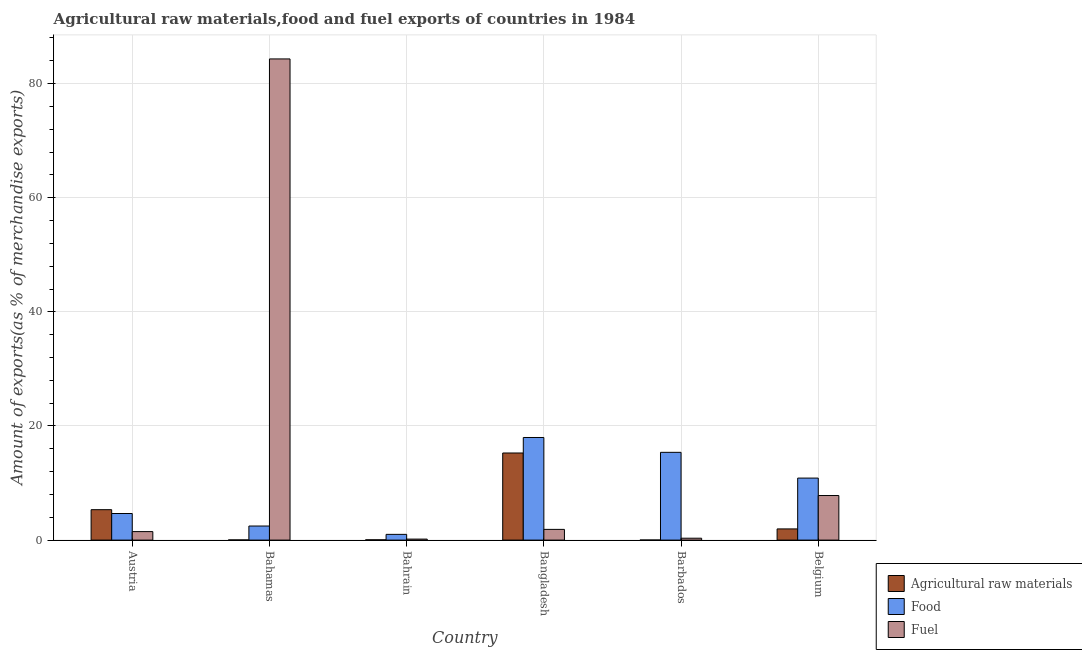Are the number of bars per tick equal to the number of legend labels?
Give a very brief answer. Yes. What is the label of the 5th group of bars from the left?
Give a very brief answer. Barbados. In how many cases, is the number of bars for a given country not equal to the number of legend labels?
Offer a very short reply. 0. What is the percentage of fuel exports in Bangladesh?
Keep it short and to the point. 1.88. Across all countries, what is the maximum percentage of food exports?
Ensure brevity in your answer.  17.98. Across all countries, what is the minimum percentage of raw materials exports?
Your response must be concise. 0.01. In which country was the percentage of food exports minimum?
Ensure brevity in your answer.  Bahrain. What is the total percentage of food exports in the graph?
Your response must be concise. 52.37. What is the difference between the percentage of fuel exports in Austria and that in Bangladesh?
Offer a very short reply. -0.39. What is the difference between the percentage of raw materials exports in Bangladesh and the percentage of food exports in Belgium?
Offer a terse response. 4.4. What is the average percentage of raw materials exports per country?
Give a very brief answer. 3.77. What is the difference between the percentage of fuel exports and percentage of raw materials exports in Bahrain?
Make the answer very short. 0.13. What is the ratio of the percentage of fuel exports in Bangladesh to that in Belgium?
Offer a terse response. 0.24. Is the difference between the percentage of food exports in Bahamas and Bangladesh greater than the difference between the percentage of raw materials exports in Bahamas and Bangladesh?
Your response must be concise. No. What is the difference between the highest and the second highest percentage of fuel exports?
Give a very brief answer. 76.52. What is the difference between the highest and the lowest percentage of fuel exports?
Offer a very short reply. 84.15. In how many countries, is the percentage of food exports greater than the average percentage of food exports taken over all countries?
Keep it short and to the point. 3. What does the 3rd bar from the left in Barbados represents?
Your response must be concise. Fuel. What does the 2nd bar from the right in Bahamas represents?
Keep it short and to the point. Food. Is it the case that in every country, the sum of the percentage of raw materials exports and percentage of food exports is greater than the percentage of fuel exports?
Offer a terse response. No. Are all the bars in the graph horizontal?
Your answer should be compact. No. Are the values on the major ticks of Y-axis written in scientific E-notation?
Give a very brief answer. No. Where does the legend appear in the graph?
Offer a terse response. Bottom right. How are the legend labels stacked?
Give a very brief answer. Vertical. What is the title of the graph?
Ensure brevity in your answer.  Agricultural raw materials,food and fuel exports of countries in 1984. Does "Textiles and clothing" appear as one of the legend labels in the graph?
Your answer should be very brief. No. What is the label or title of the Y-axis?
Ensure brevity in your answer.  Amount of exports(as % of merchandise exports). What is the Amount of exports(as % of merchandise exports) in Agricultural raw materials in Austria?
Offer a very short reply. 5.33. What is the Amount of exports(as % of merchandise exports) in Food in Austria?
Your response must be concise. 4.66. What is the Amount of exports(as % of merchandise exports) of Fuel in Austria?
Keep it short and to the point. 1.49. What is the Amount of exports(as % of merchandise exports) in Agricultural raw materials in Bahamas?
Provide a succinct answer. 0.03. What is the Amount of exports(as % of merchandise exports) in Food in Bahamas?
Make the answer very short. 2.47. What is the Amount of exports(as % of merchandise exports) of Fuel in Bahamas?
Give a very brief answer. 84.33. What is the Amount of exports(as % of merchandise exports) in Agricultural raw materials in Bahrain?
Provide a succinct answer. 0.05. What is the Amount of exports(as % of merchandise exports) in Food in Bahrain?
Your answer should be compact. 1. What is the Amount of exports(as % of merchandise exports) of Fuel in Bahrain?
Make the answer very short. 0.18. What is the Amount of exports(as % of merchandise exports) in Agricultural raw materials in Bangladesh?
Ensure brevity in your answer.  15.27. What is the Amount of exports(as % of merchandise exports) in Food in Bangladesh?
Keep it short and to the point. 17.98. What is the Amount of exports(as % of merchandise exports) in Fuel in Bangladesh?
Your answer should be very brief. 1.88. What is the Amount of exports(as % of merchandise exports) in Agricultural raw materials in Barbados?
Your answer should be very brief. 0.01. What is the Amount of exports(as % of merchandise exports) of Food in Barbados?
Offer a very short reply. 15.38. What is the Amount of exports(as % of merchandise exports) in Fuel in Barbados?
Provide a short and direct response. 0.33. What is the Amount of exports(as % of merchandise exports) of Agricultural raw materials in Belgium?
Ensure brevity in your answer.  1.96. What is the Amount of exports(as % of merchandise exports) of Food in Belgium?
Make the answer very short. 10.87. What is the Amount of exports(as % of merchandise exports) in Fuel in Belgium?
Provide a short and direct response. 7.81. Across all countries, what is the maximum Amount of exports(as % of merchandise exports) in Agricultural raw materials?
Offer a terse response. 15.27. Across all countries, what is the maximum Amount of exports(as % of merchandise exports) in Food?
Keep it short and to the point. 17.98. Across all countries, what is the maximum Amount of exports(as % of merchandise exports) of Fuel?
Ensure brevity in your answer.  84.33. Across all countries, what is the minimum Amount of exports(as % of merchandise exports) of Agricultural raw materials?
Your answer should be compact. 0.01. Across all countries, what is the minimum Amount of exports(as % of merchandise exports) of Food?
Ensure brevity in your answer.  1. Across all countries, what is the minimum Amount of exports(as % of merchandise exports) of Fuel?
Offer a terse response. 0.18. What is the total Amount of exports(as % of merchandise exports) of Agricultural raw materials in the graph?
Offer a very short reply. 22.65. What is the total Amount of exports(as % of merchandise exports) of Food in the graph?
Your answer should be very brief. 52.37. What is the total Amount of exports(as % of merchandise exports) in Fuel in the graph?
Make the answer very short. 96.01. What is the difference between the Amount of exports(as % of merchandise exports) of Agricultural raw materials in Austria and that in Bahamas?
Provide a short and direct response. 5.3. What is the difference between the Amount of exports(as % of merchandise exports) in Food in Austria and that in Bahamas?
Keep it short and to the point. 2.19. What is the difference between the Amount of exports(as % of merchandise exports) in Fuel in Austria and that in Bahamas?
Give a very brief answer. -82.84. What is the difference between the Amount of exports(as % of merchandise exports) of Agricultural raw materials in Austria and that in Bahrain?
Offer a very short reply. 5.28. What is the difference between the Amount of exports(as % of merchandise exports) in Food in Austria and that in Bahrain?
Make the answer very short. 3.66. What is the difference between the Amount of exports(as % of merchandise exports) in Fuel in Austria and that in Bahrain?
Offer a very short reply. 1.31. What is the difference between the Amount of exports(as % of merchandise exports) of Agricultural raw materials in Austria and that in Bangladesh?
Provide a short and direct response. -9.94. What is the difference between the Amount of exports(as % of merchandise exports) of Food in Austria and that in Bangladesh?
Offer a very short reply. -13.32. What is the difference between the Amount of exports(as % of merchandise exports) of Fuel in Austria and that in Bangladesh?
Offer a very short reply. -0.39. What is the difference between the Amount of exports(as % of merchandise exports) of Agricultural raw materials in Austria and that in Barbados?
Offer a very short reply. 5.32. What is the difference between the Amount of exports(as % of merchandise exports) in Food in Austria and that in Barbados?
Offer a very short reply. -10.72. What is the difference between the Amount of exports(as % of merchandise exports) in Fuel in Austria and that in Barbados?
Ensure brevity in your answer.  1.16. What is the difference between the Amount of exports(as % of merchandise exports) in Agricultural raw materials in Austria and that in Belgium?
Provide a short and direct response. 3.37. What is the difference between the Amount of exports(as % of merchandise exports) in Food in Austria and that in Belgium?
Your answer should be very brief. -6.21. What is the difference between the Amount of exports(as % of merchandise exports) of Fuel in Austria and that in Belgium?
Your answer should be very brief. -6.32. What is the difference between the Amount of exports(as % of merchandise exports) of Agricultural raw materials in Bahamas and that in Bahrain?
Provide a succinct answer. -0.02. What is the difference between the Amount of exports(as % of merchandise exports) in Food in Bahamas and that in Bahrain?
Your response must be concise. 1.46. What is the difference between the Amount of exports(as % of merchandise exports) in Fuel in Bahamas and that in Bahrain?
Provide a short and direct response. 84.15. What is the difference between the Amount of exports(as % of merchandise exports) in Agricultural raw materials in Bahamas and that in Bangladesh?
Ensure brevity in your answer.  -15.24. What is the difference between the Amount of exports(as % of merchandise exports) in Food in Bahamas and that in Bangladesh?
Your answer should be compact. -15.51. What is the difference between the Amount of exports(as % of merchandise exports) of Fuel in Bahamas and that in Bangladesh?
Your response must be concise. 82.45. What is the difference between the Amount of exports(as % of merchandise exports) in Agricultural raw materials in Bahamas and that in Barbados?
Offer a very short reply. 0.02. What is the difference between the Amount of exports(as % of merchandise exports) in Food in Bahamas and that in Barbados?
Provide a short and direct response. -12.91. What is the difference between the Amount of exports(as % of merchandise exports) in Fuel in Bahamas and that in Barbados?
Provide a short and direct response. 84. What is the difference between the Amount of exports(as % of merchandise exports) in Agricultural raw materials in Bahamas and that in Belgium?
Keep it short and to the point. -1.93. What is the difference between the Amount of exports(as % of merchandise exports) in Food in Bahamas and that in Belgium?
Your response must be concise. -8.4. What is the difference between the Amount of exports(as % of merchandise exports) in Fuel in Bahamas and that in Belgium?
Your answer should be compact. 76.52. What is the difference between the Amount of exports(as % of merchandise exports) of Agricultural raw materials in Bahrain and that in Bangladesh?
Your answer should be very brief. -15.22. What is the difference between the Amount of exports(as % of merchandise exports) of Food in Bahrain and that in Bangladesh?
Your answer should be very brief. -16.98. What is the difference between the Amount of exports(as % of merchandise exports) in Fuel in Bahrain and that in Bangladesh?
Provide a succinct answer. -1.7. What is the difference between the Amount of exports(as % of merchandise exports) of Agricultural raw materials in Bahrain and that in Barbados?
Make the answer very short. 0.04. What is the difference between the Amount of exports(as % of merchandise exports) in Food in Bahrain and that in Barbados?
Provide a succinct answer. -14.38. What is the difference between the Amount of exports(as % of merchandise exports) in Fuel in Bahrain and that in Barbados?
Provide a succinct answer. -0.15. What is the difference between the Amount of exports(as % of merchandise exports) in Agricultural raw materials in Bahrain and that in Belgium?
Provide a short and direct response. -1.91. What is the difference between the Amount of exports(as % of merchandise exports) of Food in Bahrain and that in Belgium?
Offer a terse response. -9.87. What is the difference between the Amount of exports(as % of merchandise exports) in Fuel in Bahrain and that in Belgium?
Give a very brief answer. -7.64. What is the difference between the Amount of exports(as % of merchandise exports) of Agricultural raw materials in Bangladesh and that in Barbados?
Your answer should be very brief. 15.26. What is the difference between the Amount of exports(as % of merchandise exports) in Food in Bangladesh and that in Barbados?
Your answer should be compact. 2.6. What is the difference between the Amount of exports(as % of merchandise exports) in Fuel in Bangladesh and that in Barbados?
Make the answer very short. 1.55. What is the difference between the Amount of exports(as % of merchandise exports) of Agricultural raw materials in Bangladesh and that in Belgium?
Provide a short and direct response. 13.31. What is the difference between the Amount of exports(as % of merchandise exports) of Food in Bangladesh and that in Belgium?
Give a very brief answer. 7.11. What is the difference between the Amount of exports(as % of merchandise exports) of Fuel in Bangladesh and that in Belgium?
Your answer should be very brief. -5.93. What is the difference between the Amount of exports(as % of merchandise exports) in Agricultural raw materials in Barbados and that in Belgium?
Keep it short and to the point. -1.95. What is the difference between the Amount of exports(as % of merchandise exports) in Food in Barbados and that in Belgium?
Your response must be concise. 4.51. What is the difference between the Amount of exports(as % of merchandise exports) of Fuel in Barbados and that in Belgium?
Your answer should be compact. -7.48. What is the difference between the Amount of exports(as % of merchandise exports) of Agricultural raw materials in Austria and the Amount of exports(as % of merchandise exports) of Food in Bahamas?
Keep it short and to the point. 2.86. What is the difference between the Amount of exports(as % of merchandise exports) of Agricultural raw materials in Austria and the Amount of exports(as % of merchandise exports) of Fuel in Bahamas?
Offer a very short reply. -79. What is the difference between the Amount of exports(as % of merchandise exports) in Food in Austria and the Amount of exports(as % of merchandise exports) in Fuel in Bahamas?
Provide a short and direct response. -79.67. What is the difference between the Amount of exports(as % of merchandise exports) in Agricultural raw materials in Austria and the Amount of exports(as % of merchandise exports) in Food in Bahrain?
Provide a succinct answer. 4.33. What is the difference between the Amount of exports(as % of merchandise exports) in Agricultural raw materials in Austria and the Amount of exports(as % of merchandise exports) in Fuel in Bahrain?
Your response must be concise. 5.16. What is the difference between the Amount of exports(as % of merchandise exports) of Food in Austria and the Amount of exports(as % of merchandise exports) of Fuel in Bahrain?
Offer a very short reply. 4.48. What is the difference between the Amount of exports(as % of merchandise exports) of Agricultural raw materials in Austria and the Amount of exports(as % of merchandise exports) of Food in Bangladesh?
Provide a succinct answer. -12.65. What is the difference between the Amount of exports(as % of merchandise exports) of Agricultural raw materials in Austria and the Amount of exports(as % of merchandise exports) of Fuel in Bangladesh?
Your answer should be compact. 3.45. What is the difference between the Amount of exports(as % of merchandise exports) of Food in Austria and the Amount of exports(as % of merchandise exports) of Fuel in Bangladesh?
Give a very brief answer. 2.78. What is the difference between the Amount of exports(as % of merchandise exports) of Agricultural raw materials in Austria and the Amount of exports(as % of merchandise exports) of Food in Barbados?
Offer a terse response. -10.05. What is the difference between the Amount of exports(as % of merchandise exports) in Agricultural raw materials in Austria and the Amount of exports(as % of merchandise exports) in Fuel in Barbados?
Your answer should be compact. 5. What is the difference between the Amount of exports(as % of merchandise exports) of Food in Austria and the Amount of exports(as % of merchandise exports) of Fuel in Barbados?
Keep it short and to the point. 4.33. What is the difference between the Amount of exports(as % of merchandise exports) of Agricultural raw materials in Austria and the Amount of exports(as % of merchandise exports) of Food in Belgium?
Ensure brevity in your answer.  -5.54. What is the difference between the Amount of exports(as % of merchandise exports) of Agricultural raw materials in Austria and the Amount of exports(as % of merchandise exports) of Fuel in Belgium?
Keep it short and to the point. -2.48. What is the difference between the Amount of exports(as % of merchandise exports) of Food in Austria and the Amount of exports(as % of merchandise exports) of Fuel in Belgium?
Provide a short and direct response. -3.15. What is the difference between the Amount of exports(as % of merchandise exports) in Agricultural raw materials in Bahamas and the Amount of exports(as % of merchandise exports) in Food in Bahrain?
Offer a terse response. -0.97. What is the difference between the Amount of exports(as % of merchandise exports) of Agricultural raw materials in Bahamas and the Amount of exports(as % of merchandise exports) of Fuel in Bahrain?
Offer a terse response. -0.14. What is the difference between the Amount of exports(as % of merchandise exports) of Food in Bahamas and the Amount of exports(as % of merchandise exports) of Fuel in Bahrain?
Give a very brief answer. 2.29. What is the difference between the Amount of exports(as % of merchandise exports) in Agricultural raw materials in Bahamas and the Amount of exports(as % of merchandise exports) in Food in Bangladesh?
Your response must be concise. -17.95. What is the difference between the Amount of exports(as % of merchandise exports) in Agricultural raw materials in Bahamas and the Amount of exports(as % of merchandise exports) in Fuel in Bangladesh?
Your response must be concise. -1.85. What is the difference between the Amount of exports(as % of merchandise exports) of Food in Bahamas and the Amount of exports(as % of merchandise exports) of Fuel in Bangladesh?
Your response must be concise. 0.59. What is the difference between the Amount of exports(as % of merchandise exports) of Agricultural raw materials in Bahamas and the Amount of exports(as % of merchandise exports) of Food in Barbados?
Your answer should be very brief. -15.35. What is the difference between the Amount of exports(as % of merchandise exports) of Agricultural raw materials in Bahamas and the Amount of exports(as % of merchandise exports) of Fuel in Barbados?
Offer a terse response. -0.3. What is the difference between the Amount of exports(as % of merchandise exports) in Food in Bahamas and the Amount of exports(as % of merchandise exports) in Fuel in Barbados?
Offer a very short reply. 2.14. What is the difference between the Amount of exports(as % of merchandise exports) in Agricultural raw materials in Bahamas and the Amount of exports(as % of merchandise exports) in Food in Belgium?
Provide a short and direct response. -10.84. What is the difference between the Amount of exports(as % of merchandise exports) of Agricultural raw materials in Bahamas and the Amount of exports(as % of merchandise exports) of Fuel in Belgium?
Make the answer very short. -7.78. What is the difference between the Amount of exports(as % of merchandise exports) in Food in Bahamas and the Amount of exports(as % of merchandise exports) in Fuel in Belgium?
Your answer should be compact. -5.34. What is the difference between the Amount of exports(as % of merchandise exports) of Agricultural raw materials in Bahrain and the Amount of exports(as % of merchandise exports) of Food in Bangladesh?
Your answer should be very brief. -17.93. What is the difference between the Amount of exports(as % of merchandise exports) of Agricultural raw materials in Bahrain and the Amount of exports(as % of merchandise exports) of Fuel in Bangladesh?
Your response must be concise. -1.83. What is the difference between the Amount of exports(as % of merchandise exports) of Food in Bahrain and the Amount of exports(as % of merchandise exports) of Fuel in Bangladesh?
Provide a short and direct response. -0.87. What is the difference between the Amount of exports(as % of merchandise exports) of Agricultural raw materials in Bahrain and the Amount of exports(as % of merchandise exports) of Food in Barbados?
Ensure brevity in your answer.  -15.33. What is the difference between the Amount of exports(as % of merchandise exports) of Agricultural raw materials in Bahrain and the Amount of exports(as % of merchandise exports) of Fuel in Barbados?
Offer a very short reply. -0.28. What is the difference between the Amount of exports(as % of merchandise exports) of Food in Bahrain and the Amount of exports(as % of merchandise exports) of Fuel in Barbados?
Offer a very short reply. 0.67. What is the difference between the Amount of exports(as % of merchandise exports) of Agricultural raw materials in Bahrain and the Amount of exports(as % of merchandise exports) of Food in Belgium?
Make the answer very short. -10.82. What is the difference between the Amount of exports(as % of merchandise exports) of Agricultural raw materials in Bahrain and the Amount of exports(as % of merchandise exports) of Fuel in Belgium?
Keep it short and to the point. -7.76. What is the difference between the Amount of exports(as % of merchandise exports) of Food in Bahrain and the Amount of exports(as % of merchandise exports) of Fuel in Belgium?
Offer a terse response. -6.81. What is the difference between the Amount of exports(as % of merchandise exports) of Agricultural raw materials in Bangladesh and the Amount of exports(as % of merchandise exports) of Food in Barbados?
Keep it short and to the point. -0.11. What is the difference between the Amount of exports(as % of merchandise exports) of Agricultural raw materials in Bangladesh and the Amount of exports(as % of merchandise exports) of Fuel in Barbados?
Your response must be concise. 14.94. What is the difference between the Amount of exports(as % of merchandise exports) of Food in Bangladesh and the Amount of exports(as % of merchandise exports) of Fuel in Barbados?
Your answer should be compact. 17.65. What is the difference between the Amount of exports(as % of merchandise exports) of Agricultural raw materials in Bangladesh and the Amount of exports(as % of merchandise exports) of Food in Belgium?
Ensure brevity in your answer.  4.4. What is the difference between the Amount of exports(as % of merchandise exports) of Agricultural raw materials in Bangladesh and the Amount of exports(as % of merchandise exports) of Fuel in Belgium?
Your response must be concise. 7.45. What is the difference between the Amount of exports(as % of merchandise exports) of Food in Bangladesh and the Amount of exports(as % of merchandise exports) of Fuel in Belgium?
Your answer should be very brief. 10.17. What is the difference between the Amount of exports(as % of merchandise exports) in Agricultural raw materials in Barbados and the Amount of exports(as % of merchandise exports) in Food in Belgium?
Give a very brief answer. -10.86. What is the difference between the Amount of exports(as % of merchandise exports) in Agricultural raw materials in Barbados and the Amount of exports(as % of merchandise exports) in Fuel in Belgium?
Give a very brief answer. -7.8. What is the difference between the Amount of exports(as % of merchandise exports) of Food in Barbados and the Amount of exports(as % of merchandise exports) of Fuel in Belgium?
Make the answer very short. 7.57. What is the average Amount of exports(as % of merchandise exports) of Agricultural raw materials per country?
Provide a short and direct response. 3.77. What is the average Amount of exports(as % of merchandise exports) of Food per country?
Offer a terse response. 8.73. What is the average Amount of exports(as % of merchandise exports) of Fuel per country?
Give a very brief answer. 16. What is the difference between the Amount of exports(as % of merchandise exports) in Agricultural raw materials and Amount of exports(as % of merchandise exports) in Food in Austria?
Make the answer very short. 0.67. What is the difference between the Amount of exports(as % of merchandise exports) in Agricultural raw materials and Amount of exports(as % of merchandise exports) in Fuel in Austria?
Your response must be concise. 3.84. What is the difference between the Amount of exports(as % of merchandise exports) of Food and Amount of exports(as % of merchandise exports) of Fuel in Austria?
Your response must be concise. 3.17. What is the difference between the Amount of exports(as % of merchandise exports) of Agricultural raw materials and Amount of exports(as % of merchandise exports) of Food in Bahamas?
Your answer should be very brief. -2.44. What is the difference between the Amount of exports(as % of merchandise exports) of Agricultural raw materials and Amount of exports(as % of merchandise exports) of Fuel in Bahamas?
Ensure brevity in your answer.  -84.3. What is the difference between the Amount of exports(as % of merchandise exports) of Food and Amount of exports(as % of merchandise exports) of Fuel in Bahamas?
Make the answer very short. -81.86. What is the difference between the Amount of exports(as % of merchandise exports) in Agricultural raw materials and Amount of exports(as % of merchandise exports) in Food in Bahrain?
Your answer should be very brief. -0.95. What is the difference between the Amount of exports(as % of merchandise exports) of Agricultural raw materials and Amount of exports(as % of merchandise exports) of Fuel in Bahrain?
Give a very brief answer. -0.13. What is the difference between the Amount of exports(as % of merchandise exports) in Food and Amount of exports(as % of merchandise exports) in Fuel in Bahrain?
Your answer should be very brief. 0.83. What is the difference between the Amount of exports(as % of merchandise exports) of Agricultural raw materials and Amount of exports(as % of merchandise exports) of Food in Bangladesh?
Give a very brief answer. -2.72. What is the difference between the Amount of exports(as % of merchandise exports) of Agricultural raw materials and Amount of exports(as % of merchandise exports) of Fuel in Bangladesh?
Give a very brief answer. 13.39. What is the difference between the Amount of exports(as % of merchandise exports) of Food and Amount of exports(as % of merchandise exports) of Fuel in Bangladesh?
Offer a very short reply. 16.11. What is the difference between the Amount of exports(as % of merchandise exports) of Agricultural raw materials and Amount of exports(as % of merchandise exports) of Food in Barbados?
Offer a terse response. -15.37. What is the difference between the Amount of exports(as % of merchandise exports) of Agricultural raw materials and Amount of exports(as % of merchandise exports) of Fuel in Barbados?
Your response must be concise. -0.32. What is the difference between the Amount of exports(as % of merchandise exports) in Food and Amount of exports(as % of merchandise exports) in Fuel in Barbados?
Keep it short and to the point. 15.05. What is the difference between the Amount of exports(as % of merchandise exports) of Agricultural raw materials and Amount of exports(as % of merchandise exports) of Food in Belgium?
Your response must be concise. -8.91. What is the difference between the Amount of exports(as % of merchandise exports) of Agricultural raw materials and Amount of exports(as % of merchandise exports) of Fuel in Belgium?
Offer a very short reply. -5.85. What is the difference between the Amount of exports(as % of merchandise exports) in Food and Amount of exports(as % of merchandise exports) in Fuel in Belgium?
Offer a very short reply. 3.06. What is the ratio of the Amount of exports(as % of merchandise exports) in Agricultural raw materials in Austria to that in Bahamas?
Offer a terse response. 173.82. What is the ratio of the Amount of exports(as % of merchandise exports) of Food in Austria to that in Bahamas?
Give a very brief answer. 1.89. What is the ratio of the Amount of exports(as % of merchandise exports) of Fuel in Austria to that in Bahamas?
Make the answer very short. 0.02. What is the ratio of the Amount of exports(as % of merchandise exports) of Agricultural raw materials in Austria to that in Bahrain?
Give a very brief answer. 106.8. What is the ratio of the Amount of exports(as % of merchandise exports) in Food in Austria to that in Bahrain?
Give a very brief answer. 4.64. What is the ratio of the Amount of exports(as % of merchandise exports) of Fuel in Austria to that in Bahrain?
Make the answer very short. 8.48. What is the ratio of the Amount of exports(as % of merchandise exports) in Agricultural raw materials in Austria to that in Bangladesh?
Your answer should be very brief. 0.35. What is the ratio of the Amount of exports(as % of merchandise exports) in Food in Austria to that in Bangladesh?
Ensure brevity in your answer.  0.26. What is the ratio of the Amount of exports(as % of merchandise exports) in Fuel in Austria to that in Bangladesh?
Your answer should be compact. 0.79. What is the ratio of the Amount of exports(as % of merchandise exports) of Agricultural raw materials in Austria to that in Barbados?
Provide a short and direct response. 491.68. What is the ratio of the Amount of exports(as % of merchandise exports) in Food in Austria to that in Barbados?
Offer a very short reply. 0.3. What is the ratio of the Amount of exports(as % of merchandise exports) in Fuel in Austria to that in Barbados?
Offer a very short reply. 4.51. What is the ratio of the Amount of exports(as % of merchandise exports) of Agricultural raw materials in Austria to that in Belgium?
Your answer should be compact. 2.72. What is the ratio of the Amount of exports(as % of merchandise exports) in Food in Austria to that in Belgium?
Give a very brief answer. 0.43. What is the ratio of the Amount of exports(as % of merchandise exports) of Fuel in Austria to that in Belgium?
Provide a short and direct response. 0.19. What is the ratio of the Amount of exports(as % of merchandise exports) in Agricultural raw materials in Bahamas to that in Bahrain?
Keep it short and to the point. 0.61. What is the ratio of the Amount of exports(as % of merchandise exports) of Food in Bahamas to that in Bahrain?
Provide a succinct answer. 2.46. What is the ratio of the Amount of exports(as % of merchandise exports) in Fuel in Bahamas to that in Bahrain?
Offer a very short reply. 480.2. What is the ratio of the Amount of exports(as % of merchandise exports) in Agricultural raw materials in Bahamas to that in Bangladesh?
Your answer should be very brief. 0. What is the ratio of the Amount of exports(as % of merchandise exports) in Food in Bahamas to that in Bangladesh?
Provide a short and direct response. 0.14. What is the ratio of the Amount of exports(as % of merchandise exports) in Fuel in Bahamas to that in Bangladesh?
Offer a very short reply. 44.92. What is the ratio of the Amount of exports(as % of merchandise exports) in Agricultural raw materials in Bahamas to that in Barbados?
Provide a succinct answer. 2.83. What is the ratio of the Amount of exports(as % of merchandise exports) of Food in Bahamas to that in Barbados?
Ensure brevity in your answer.  0.16. What is the ratio of the Amount of exports(as % of merchandise exports) of Fuel in Bahamas to that in Barbados?
Your answer should be very brief. 255.24. What is the ratio of the Amount of exports(as % of merchandise exports) in Agricultural raw materials in Bahamas to that in Belgium?
Offer a terse response. 0.02. What is the ratio of the Amount of exports(as % of merchandise exports) in Food in Bahamas to that in Belgium?
Ensure brevity in your answer.  0.23. What is the ratio of the Amount of exports(as % of merchandise exports) in Fuel in Bahamas to that in Belgium?
Offer a very short reply. 10.79. What is the ratio of the Amount of exports(as % of merchandise exports) in Agricultural raw materials in Bahrain to that in Bangladesh?
Make the answer very short. 0. What is the ratio of the Amount of exports(as % of merchandise exports) of Food in Bahrain to that in Bangladesh?
Your response must be concise. 0.06. What is the ratio of the Amount of exports(as % of merchandise exports) in Fuel in Bahrain to that in Bangladesh?
Your answer should be very brief. 0.09. What is the ratio of the Amount of exports(as % of merchandise exports) of Agricultural raw materials in Bahrain to that in Barbados?
Ensure brevity in your answer.  4.6. What is the ratio of the Amount of exports(as % of merchandise exports) of Food in Bahrain to that in Barbados?
Provide a short and direct response. 0.07. What is the ratio of the Amount of exports(as % of merchandise exports) in Fuel in Bahrain to that in Barbados?
Provide a succinct answer. 0.53. What is the ratio of the Amount of exports(as % of merchandise exports) in Agricultural raw materials in Bahrain to that in Belgium?
Your answer should be very brief. 0.03. What is the ratio of the Amount of exports(as % of merchandise exports) in Food in Bahrain to that in Belgium?
Provide a short and direct response. 0.09. What is the ratio of the Amount of exports(as % of merchandise exports) in Fuel in Bahrain to that in Belgium?
Ensure brevity in your answer.  0.02. What is the ratio of the Amount of exports(as % of merchandise exports) in Agricultural raw materials in Bangladesh to that in Barbados?
Your response must be concise. 1408.07. What is the ratio of the Amount of exports(as % of merchandise exports) in Food in Bangladesh to that in Barbados?
Make the answer very short. 1.17. What is the ratio of the Amount of exports(as % of merchandise exports) of Fuel in Bangladesh to that in Barbados?
Your response must be concise. 5.68. What is the ratio of the Amount of exports(as % of merchandise exports) of Agricultural raw materials in Bangladesh to that in Belgium?
Make the answer very short. 7.79. What is the ratio of the Amount of exports(as % of merchandise exports) of Food in Bangladesh to that in Belgium?
Your response must be concise. 1.65. What is the ratio of the Amount of exports(as % of merchandise exports) of Fuel in Bangladesh to that in Belgium?
Ensure brevity in your answer.  0.24. What is the ratio of the Amount of exports(as % of merchandise exports) in Agricultural raw materials in Barbados to that in Belgium?
Provide a succinct answer. 0.01. What is the ratio of the Amount of exports(as % of merchandise exports) in Food in Barbados to that in Belgium?
Offer a terse response. 1.42. What is the ratio of the Amount of exports(as % of merchandise exports) in Fuel in Barbados to that in Belgium?
Give a very brief answer. 0.04. What is the difference between the highest and the second highest Amount of exports(as % of merchandise exports) in Agricultural raw materials?
Your response must be concise. 9.94. What is the difference between the highest and the second highest Amount of exports(as % of merchandise exports) of Food?
Make the answer very short. 2.6. What is the difference between the highest and the second highest Amount of exports(as % of merchandise exports) of Fuel?
Ensure brevity in your answer.  76.52. What is the difference between the highest and the lowest Amount of exports(as % of merchandise exports) of Agricultural raw materials?
Keep it short and to the point. 15.26. What is the difference between the highest and the lowest Amount of exports(as % of merchandise exports) of Food?
Offer a very short reply. 16.98. What is the difference between the highest and the lowest Amount of exports(as % of merchandise exports) of Fuel?
Offer a terse response. 84.15. 